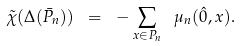Convert formula to latex. <formula><loc_0><loc_0><loc_500><loc_500>\tilde { \chi } ( \Delta ( \bar { P } _ { n } ) ) \ = \ - \sum _ { x \in P _ { n } } \ \mu _ { n } ( \hat { 0 } , x ) .</formula> 